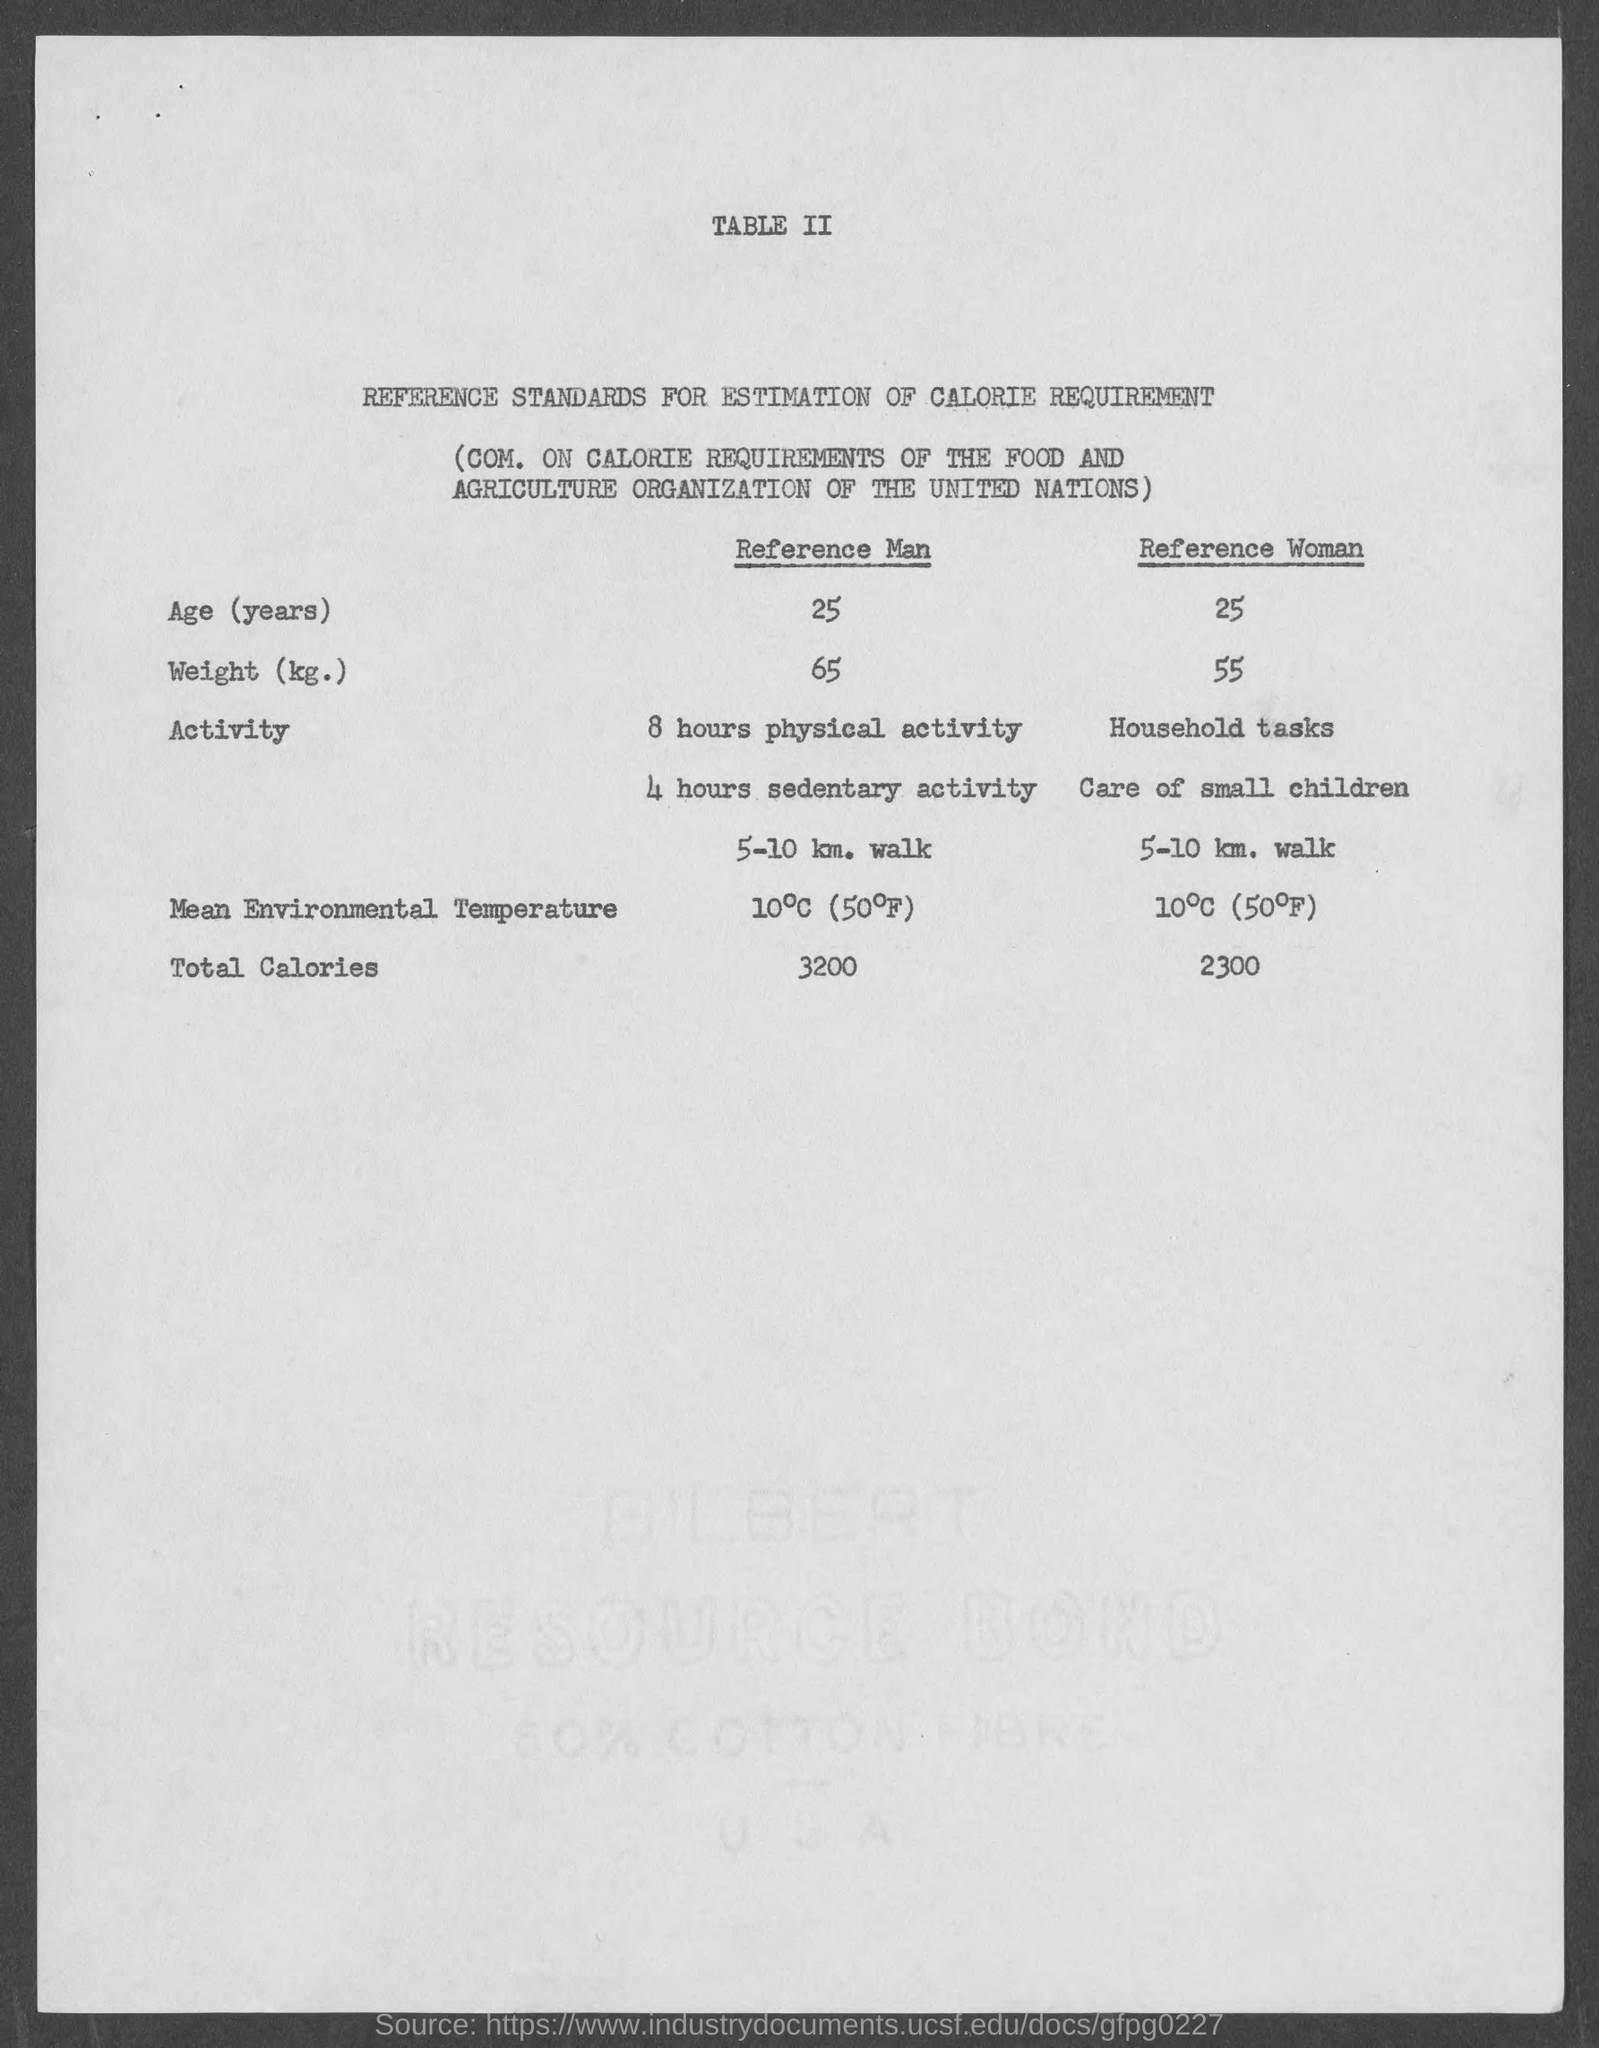What is the title of table ii ?
Your answer should be very brief. Reference Standards for Estimation of Calorie Requirement. What is the total calories for reference man ?
Offer a terse response. 3200 cal. What is the total calories for reference woman?
Make the answer very short. 2300 cal. 